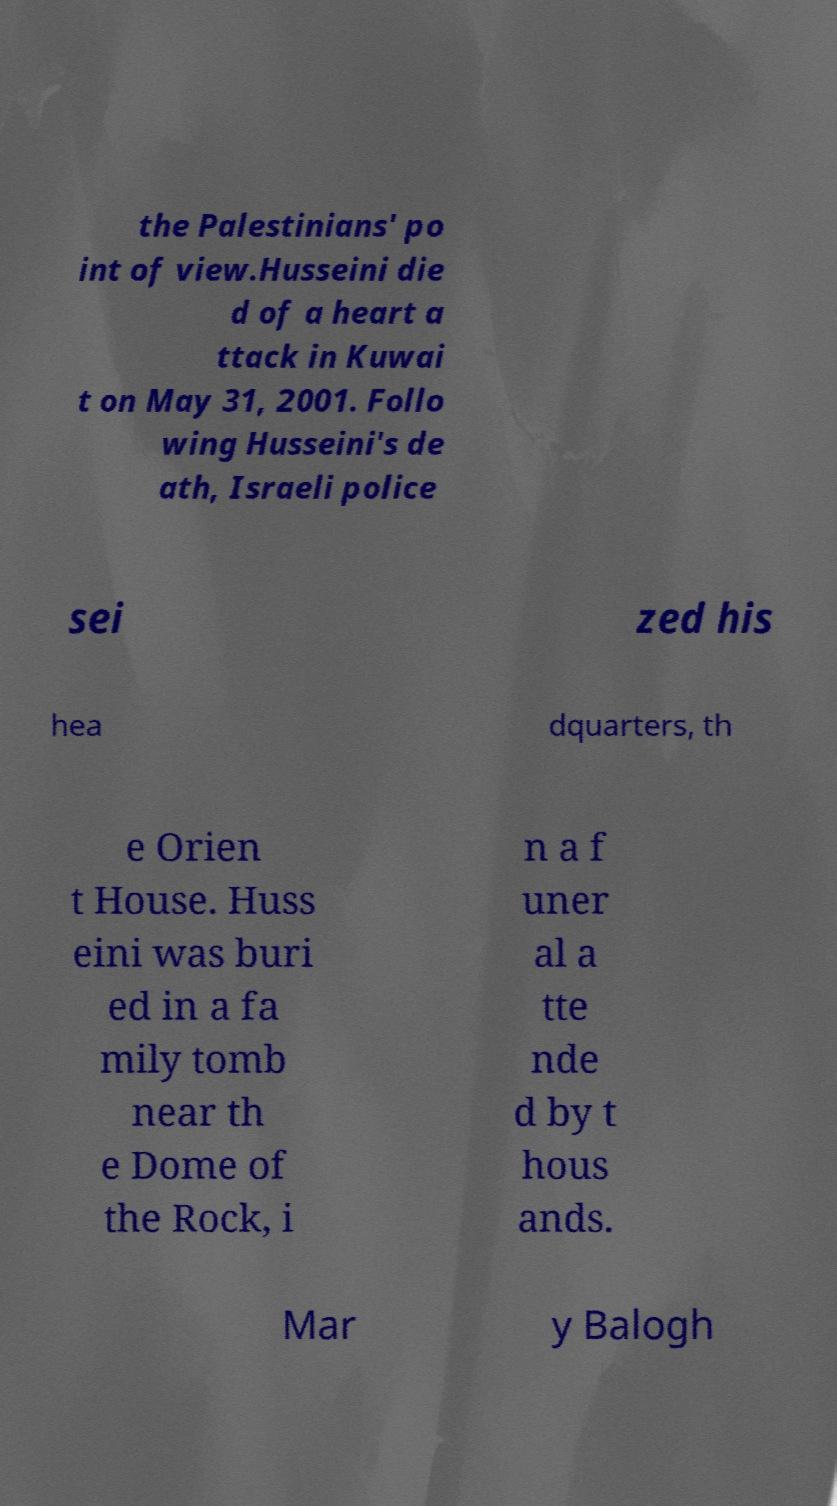Can you accurately transcribe the text from the provided image for me? the Palestinians' po int of view.Husseini die d of a heart a ttack in Kuwai t on May 31, 2001. Follo wing Husseini's de ath, Israeli police sei zed his hea dquarters, th e Orien t House. Huss eini was buri ed in a fa mily tomb near th e Dome of the Rock, i n a f uner al a tte nde d by t hous ands. Mar y Balogh 